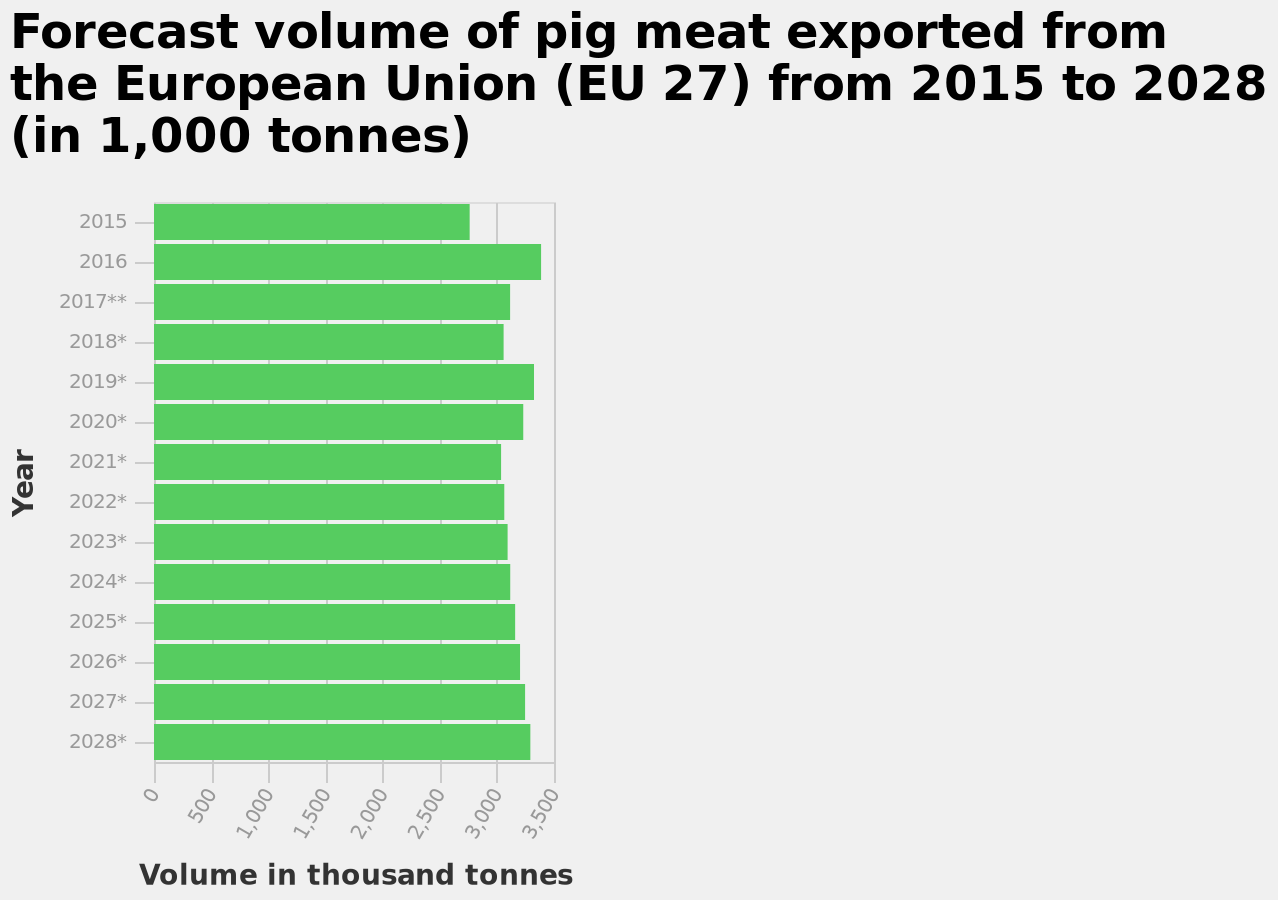<image>
please summary the statistics and relations of the chart from 2021 onward the amount of pig meat to be exported steadily increases. in 2016 and 2019 exportation peaked the highest. in 2015 the least pig meat was exported. What is the title of the graph?  The graph is titled "Forecast volume of pig meat exported from the European Union (EU 27) from 2015 to 2028 (in 1,000 tonnes)". What does the graph show about pig meat exports from the European Union? The graph displays the forecasted volume of pig meat exported from the European Union (EU 27) in thousands of tonnes, from 2015 to 2028. 